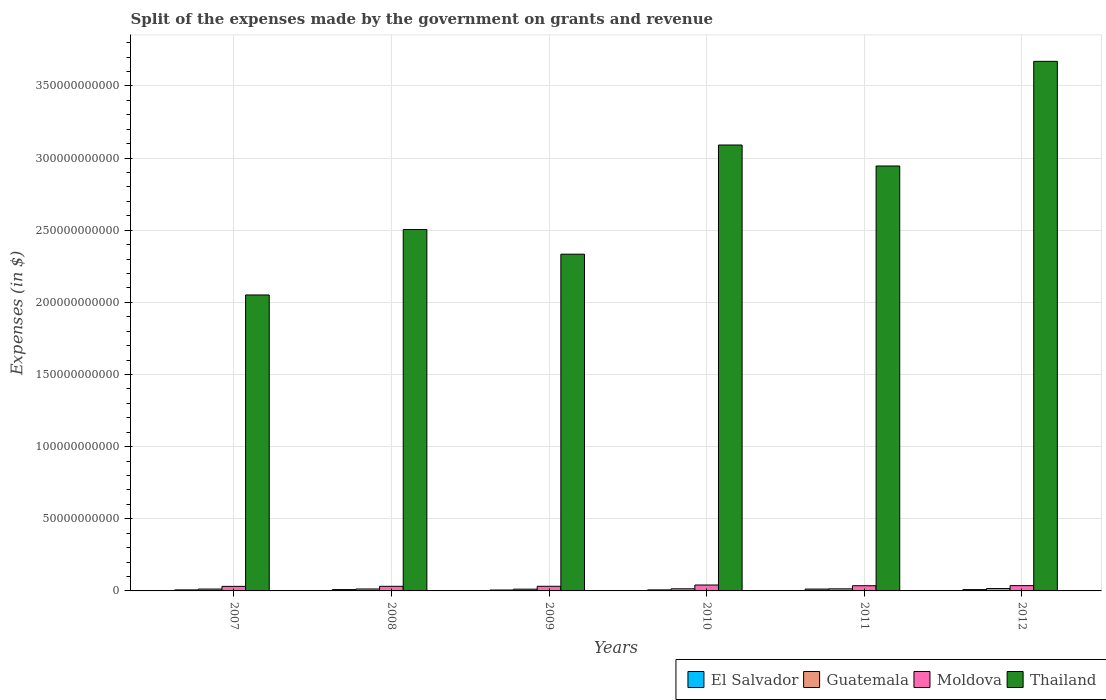How many groups of bars are there?
Offer a very short reply. 6. Are the number of bars per tick equal to the number of legend labels?
Give a very brief answer. Yes. In how many cases, is the number of bars for a given year not equal to the number of legend labels?
Provide a short and direct response. 0. What is the expenses made by the government on grants and revenue in El Salvador in 2010?
Keep it short and to the point. 7.09e+08. Across all years, what is the maximum expenses made by the government on grants and revenue in Thailand?
Your response must be concise. 3.67e+11. Across all years, what is the minimum expenses made by the government on grants and revenue in Guatemala?
Offer a terse response. 1.22e+09. In which year was the expenses made by the government on grants and revenue in Guatemala minimum?
Provide a short and direct response. 2009. What is the total expenses made by the government on grants and revenue in El Salvador in the graph?
Keep it short and to the point. 5.16e+09. What is the difference between the expenses made by the government on grants and revenue in Thailand in 2008 and that in 2012?
Provide a short and direct response. -1.17e+11. What is the difference between the expenses made by the government on grants and revenue in Guatemala in 2010 and the expenses made by the government on grants and revenue in Moldova in 2012?
Your answer should be very brief. -2.20e+09. What is the average expenses made by the government on grants and revenue in El Salvador per year?
Your response must be concise. 8.60e+08. In the year 2010, what is the difference between the expenses made by the government on grants and revenue in Guatemala and expenses made by the government on grants and revenue in El Salvador?
Offer a terse response. 7.56e+08. In how many years, is the expenses made by the government on grants and revenue in Thailand greater than 40000000000 $?
Provide a short and direct response. 6. What is the ratio of the expenses made by the government on grants and revenue in El Salvador in 2008 to that in 2010?
Provide a succinct answer. 1.3. Is the expenses made by the government on grants and revenue in Thailand in 2008 less than that in 2012?
Keep it short and to the point. Yes. Is the difference between the expenses made by the government on grants and revenue in Guatemala in 2008 and 2010 greater than the difference between the expenses made by the government on grants and revenue in El Salvador in 2008 and 2010?
Your answer should be compact. No. What is the difference between the highest and the second highest expenses made by the government on grants and revenue in Guatemala?
Your answer should be very brief. 1.70e+08. What is the difference between the highest and the lowest expenses made by the government on grants and revenue in Moldova?
Provide a succinct answer. 9.43e+08. In how many years, is the expenses made by the government on grants and revenue in Moldova greater than the average expenses made by the government on grants and revenue in Moldova taken over all years?
Your answer should be compact. 3. What does the 4th bar from the left in 2007 represents?
Keep it short and to the point. Thailand. What does the 1st bar from the right in 2009 represents?
Provide a short and direct response. Thailand. Is it the case that in every year, the sum of the expenses made by the government on grants and revenue in Thailand and expenses made by the government on grants and revenue in El Salvador is greater than the expenses made by the government on grants and revenue in Guatemala?
Provide a short and direct response. Yes. Are all the bars in the graph horizontal?
Offer a terse response. No. How many years are there in the graph?
Give a very brief answer. 6. What is the difference between two consecutive major ticks on the Y-axis?
Give a very brief answer. 5.00e+1. Does the graph contain grids?
Keep it short and to the point. Yes. How many legend labels are there?
Your answer should be compact. 4. How are the legend labels stacked?
Offer a terse response. Horizontal. What is the title of the graph?
Your answer should be compact. Split of the expenses made by the government on grants and revenue. Does "Virgin Islands" appear as one of the legend labels in the graph?
Your answer should be very brief. No. What is the label or title of the Y-axis?
Offer a very short reply. Expenses (in $). What is the Expenses (in $) in El Salvador in 2007?
Your answer should be very brief. 7.05e+08. What is the Expenses (in $) of Guatemala in 2007?
Keep it short and to the point. 1.30e+09. What is the Expenses (in $) in Moldova in 2007?
Offer a terse response. 3.16e+09. What is the Expenses (in $) in Thailand in 2007?
Offer a terse response. 2.05e+11. What is the Expenses (in $) of El Salvador in 2008?
Your answer should be very brief. 9.26e+08. What is the Expenses (in $) of Guatemala in 2008?
Give a very brief answer. 1.35e+09. What is the Expenses (in $) in Moldova in 2008?
Offer a terse response. 3.19e+09. What is the Expenses (in $) of Thailand in 2008?
Ensure brevity in your answer.  2.50e+11. What is the Expenses (in $) of El Salvador in 2009?
Give a very brief answer. 6.34e+08. What is the Expenses (in $) of Guatemala in 2009?
Provide a succinct answer. 1.22e+09. What is the Expenses (in $) of Moldova in 2009?
Your answer should be compact. 3.21e+09. What is the Expenses (in $) of Thailand in 2009?
Your answer should be compact. 2.33e+11. What is the Expenses (in $) of El Salvador in 2010?
Ensure brevity in your answer.  7.09e+08. What is the Expenses (in $) of Guatemala in 2010?
Offer a very short reply. 1.47e+09. What is the Expenses (in $) in Moldova in 2010?
Offer a very short reply. 4.10e+09. What is the Expenses (in $) of Thailand in 2010?
Your answer should be very brief. 3.09e+11. What is the Expenses (in $) in El Salvador in 2011?
Make the answer very short. 1.28e+09. What is the Expenses (in $) of Guatemala in 2011?
Provide a succinct answer. 1.44e+09. What is the Expenses (in $) in Moldova in 2011?
Provide a succinct answer. 3.61e+09. What is the Expenses (in $) in Thailand in 2011?
Provide a succinct answer. 2.95e+11. What is the Expenses (in $) in El Salvador in 2012?
Make the answer very short. 9.08e+08. What is the Expenses (in $) of Guatemala in 2012?
Your response must be concise. 1.64e+09. What is the Expenses (in $) of Moldova in 2012?
Offer a very short reply. 3.66e+09. What is the Expenses (in $) of Thailand in 2012?
Your answer should be compact. 3.67e+11. Across all years, what is the maximum Expenses (in $) of El Salvador?
Your response must be concise. 1.28e+09. Across all years, what is the maximum Expenses (in $) of Guatemala?
Keep it short and to the point. 1.64e+09. Across all years, what is the maximum Expenses (in $) of Moldova?
Keep it short and to the point. 4.10e+09. Across all years, what is the maximum Expenses (in $) of Thailand?
Provide a short and direct response. 3.67e+11. Across all years, what is the minimum Expenses (in $) in El Salvador?
Your answer should be compact. 6.34e+08. Across all years, what is the minimum Expenses (in $) of Guatemala?
Provide a short and direct response. 1.22e+09. Across all years, what is the minimum Expenses (in $) in Moldova?
Provide a short and direct response. 3.16e+09. Across all years, what is the minimum Expenses (in $) of Thailand?
Your answer should be compact. 2.05e+11. What is the total Expenses (in $) in El Salvador in the graph?
Offer a very short reply. 5.16e+09. What is the total Expenses (in $) in Guatemala in the graph?
Your response must be concise. 8.40e+09. What is the total Expenses (in $) in Moldova in the graph?
Ensure brevity in your answer.  2.09e+1. What is the total Expenses (in $) in Thailand in the graph?
Offer a very short reply. 1.66e+12. What is the difference between the Expenses (in $) in El Salvador in 2007 and that in 2008?
Make the answer very short. -2.20e+08. What is the difference between the Expenses (in $) in Guatemala in 2007 and that in 2008?
Offer a terse response. -4.95e+07. What is the difference between the Expenses (in $) of Moldova in 2007 and that in 2008?
Your answer should be compact. -3.39e+07. What is the difference between the Expenses (in $) of Thailand in 2007 and that in 2008?
Offer a very short reply. -4.54e+1. What is the difference between the Expenses (in $) in El Salvador in 2007 and that in 2009?
Your answer should be compact. 7.15e+07. What is the difference between the Expenses (in $) of Guatemala in 2007 and that in 2009?
Your response must be concise. 8.03e+07. What is the difference between the Expenses (in $) in Moldova in 2007 and that in 2009?
Give a very brief answer. -4.89e+07. What is the difference between the Expenses (in $) of Thailand in 2007 and that in 2009?
Give a very brief answer. -2.83e+1. What is the difference between the Expenses (in $) of El Salvador in 2007 and that in 2010?
Provide a short and direct response. -4.20e+06. What is the difference between the Expenses (in $) of Guatemala in 2007 and that in 2010?
Offer a very short reply. -1.69e+08. What is the difference between the Expenses (in $) of Moldova in 2007 and that in 2010?
Ensure brevity in your answer.  -9.43e+08. What is the difference between the Expenses (in $) in Thailand in 2007 and that in 2010?
Your response must be concise. -1.04e+11. What is the difference between the Expenses (in $) of El Salvador in 2007 and that in 2011?
Your response must be concise. -5.74e+08. What is the difference between the Expenses (in $) in Guatemala in 2007 and that in 2011?
Offer a terse response. -1.44e+08. What is the difference between the Expenses (in $) in Moldova in 2007 and that in 2011?
Keep it short and to the point. -4.45e+08. What is the difference between the Expenses (in $) of Thailand in 2007 and that in 2011?
Your response must be concise. -8.94e+1. What is the difference between the Expenses (in $) in El Salvador in 2007 and that in 2012?
Your response must be concise. -2.03e+08. What is the difference between the Expenses (in $) in Guatemala in 2007 and that in 2012?
Give a very brief answer. -3.39e+08. What is the difference between the Expenses (in $) of Moldova in 2007 and that in 2012?
Provide a short and direct response. -5.01e+08. What is the difference between the Expenses (in $) of Thailand in 2007 and that in 2012?
Keep it short and to the point. -1.62e+11. What is the difference between the Expenses (in $) of El Salvador in 2008 and that in 2009?
Your response must be concise. 2.92e+08. What is the difference between the Expenses (in $) in Guatemala in 2008 and that in 2009?
Offer a terse response. 1.30e+08. What is the difference between the Expenses (in $) of Moldova in 2008 and that in 2009?
Provide a short and direct response. -1.50e+07. What is the difference between the Expenses (in $) of Thailand in 2008 and that in 2009?
Give a very brief answer. 1.71e+1. What is the difference between the Expenses (in $) in El Salvador in 2008 and that in 2010?
Offer a terse response. 2.16e+08. What is the difference between the Expenses (in $) of Guatemala in 2008 and that in 2010?
Give a very brief answer. -1.20e+08. What is the difference between the Expenses (in $) in Moldova in 2008 and that in 2010?
Ensure brevity in your answer.  -9.09e+08. What is the difference between the Expenses (in $) of Thailand in 2008 and that in 2010?
Provide a succinct answer. -5.86e+1. What is the difference between the Expenses (in $) of El Salvador in 2008 and that in 2011?
Offer a very short reply. -3.54e+08. What is the difference between the Expenses (in $) of Guatemala in 2008 and that in 2011?
Your answer should be very brief. -9.49e+07. What is the difference between the Expenses (in $) of Moldova in 2008 and that in 2011?
Your answer should be compact. -4.11e+08. What is the difference between the Expenses (in $) in Thailand in 2008 and that in 2011?
Provide a short and direct response. -4.41e+1. What is the difference between the Expenses (in $) of El Salvador in 2008 and that in 2012?
Provide a succinct answer. 1.77e+07. What is the difference between the Expenses (in $) of Guatemala in 2008 and that in 2012?
Your answer should be compact. -2.90e+08. What is the difference between the Expenses (in $) of Moldova in 2008 and that in 2012?
Provide a succinct answer. -4.67e+08. What is the difference between the Expenses (in $) in Thailand in 2008 and that in 2012?
Make the answer very short. -1.17e+11. What is the difference between the Expenses (in $) in El Salvador in 2009 and that in 2010?
Keep it short and to the point. -7.57e+07. What is the difference between the Expenses (in $) in Guatemala in 2009 and that in 2010?
Offer a terse response. -2.49e+08. What is the difference between the Expenses (in $) in Moldova in 2009 and that in 2010?
Your response must be concise. -8.94e+08. What is the difference between the Expenses (in $) of Thailand in 2009 and that in 2010?
Provide a succinct answer. -7.57e+1. What is the difference between the Expenses (in $) in El Salvador in 2009 and that in 2011?
Your answer should be very brief. -6.46e+08. What is the difference between the Expenses (in $) of Guatemala in 2009 and that in 2011?
Provide a short and direct response. -2.25e+08. What is the difference between the Expenses (in $) in Moldova in 2009 and that in 2011?
Offer a very short reply. -3.96e+08. What is the difference between the Expenses (in $) in Thailand in 2009 and that in 2011?
Your answer should be compact. -6.11e+1. What is the difference between the Expenses (in $) of El Salvador in 2009 and that in 2012?
Offer a terse response. -2.74e+08. What is the difference between the Expenses (in $) of Guatemala in 2009 and that in 2012?
Provide a succinct answer. -4.20e+08. What is the difference between the Expenses (in $) of Moldova in 2009 and that in 2012?
Your response must be concise. -4.52e+08. What is the difference between the Expenses (in $) in Thailand in 2009 and that in 2012?
Your response must be concise. -1.34e+11. What is the difference between the Expenses (in $) in El Salvador in 2010 and that in 2011?
Keep it short and to the point. -5.70e+08. What is the difference between the Expenses (in $) in Guatemala in 2010 and that in 2011?
Your response must be concise. 2.46e+07. What is the difference between the Expenses (in $) in Moldova in 2010 and that in 2011?
Keep it short and to the point. 4.98e+08. What is the difference between the Expenses (in $) in Thailand in 2010 and that in 2011?
Offer a very short reply. 1.45e+1. What is the difference between the Expenses (in $) in El Salvador in 2010 and that in 2012?
Provide a short and direct response. -1.98e+08. What is the difference between the Expenses (in $) of Guatemala in 2010 and that in 2012?
Make the answer very short. -1.70e+08. What is the difference between the Expenses (in $) in Moldova in 2010 and that in 2012?
Give a very brief answer. 4.42e+08. What is the difference between the Expenses (in $) of Thailand in 2010 and that in 2012?
Keep it short and to the point. -5.80e+1. What is the difference between the Expenses (in $) of El Salvador in 2011 and that in 2012?
Your answer should be very brief. 3.72e+08. What is the difference between the Expenses (in $) of Guatemala in 2011 and that in 2012?
Your response must be concise. -1.95e+08. What is the difference between the Expenses (in $) in Moldova in 2011 and that in 2012?
Provide a succinct answer. -5.60e+07. What is the difference between the Expenses (in $) of Thailand in 2011 and that in 2012?
Give a very brief answer. -7.25e+1. What is the difference between the Expenses (in $) in El Salvador in 2007 and the Expenses (in $) in Guatemala in 2008?
Provide a succinct answer. -6.41e+08. What is the difference between the Expenses (in $) in El Salvador in 2007 and the Expenses (in $) in Moldova in 2008?
Your response must be concise. -2.49e+09. What is the difference between the Expenses (in $) of El Salvador in 2007 and the Expenses (in $) of Thailand in 2008?
Offer a very short reply. -2.50e+11. What is the difference between the Expenses (in $) in Guatemala in 2007 and the Expenses (in $) in Moldova in 2008?
Give a very brief answer. -1.90e+09. What is the difference between the Expenses (in $) of Guatemala in 2007 and the Expenses (in $) of Thailand in 2008?
Ensure brevity in your answer.  -2.49e+11. What is the difference between the Expenses (in $) in Moldova in 2007 and the Expenses (in $) in Thailand in 2008?
Provide a succinct answer. -2.47e+11. What is the difference between the Expenses (in $) in El Salvador in 2007 and the Expenses (in $) in Guatemala in 2009?
Offer a very short reply. -5.11e+08. What is the difference between the Expenses (in $) in El Salvador in 2007 and the Expenses (in $) in Moldova in 2009?
Keep it short and to the point. -2.50e+09. What is the difference between the Expenses (in $) of El Salvador in 2007 and the Expenses (in $) of Thailand in 2009?
Provide a succinct answer. -2.33e+11. What is the difference between the Expenses (in $) of Guatemala in 2007 and the Expenses (in $) of Moldova in 2009?
Give a very brief answer. -1.91e+09. What is the difference between the Expenses (in $) of Guatemala in 2007 and the Expenses (in $) of Thailand in 2009?
Offer a terse response. -2.32e+11. What is the difference between the Expenses (in $) of Moldova in 2007 and the Expenses (in $) of Thailand in 2009?
Your response must be concise. -2.30e+11. What is the difference between the Expenses (in $) in El Salvador in 2007 and the Expenses (in $) in Guatemala in 2010?
Provide a succinct answer. -7.60e+08. What is the difference between the Expenses (in $) of El Salvador in 2007 and the Expenses (in $) of Moldova in 2010?
Provide a short and direct response. -3.40e+09. What is the difference between the Expenses (in $) in El Salvador in 2007 and the Expenses (in $) in Thailand in 2010?
Your answer should be compact. -3.08e+11. What is the difference between the Expenses (in $) of Guatemala in 2007 and the Expenses (in $) of Moldova in 2010?
Make the answer very short. -2.81e+09. What is the difference between the Expenses (in $) of Guatemala in 2007 and the Expenses (in $) of Thailand in 2010?
Ensure brevity in your answer.  -3.08e+11. What is the difference between the Expenses (in $) in Moldova in 2007 and the Expenses (in $) in Thailand in 2010?
Give a very brief answer. -3.06e+11. What is the difference between the Expenses (in $) of El Salvador in 2007 and the Expenses (in $) of Guatemala in 2011?
Provide a succinct answer. -7.36e+08. What is the difference between the Expenses (in $) of El Salvador in 2007 and the Expenses (in $) of Moldova in 2011?
Offer a terse response. -2.90e+09. What is the difference between the Expenses (in $) of El Salvador in 2007 and the Expenses (in $) of Thailand in 2011?
Make the answer very short. -2.94e+11. What is the difference between the Expenses (in $) of Guatemala in 2007 and the Expenses (in $) of Moldova in 2011?
Your answer should be compact. -2.31e+09. What is the difference between the Expenses (in $) of Guatemala in 2007 and the Expenses (in $) of Thailand in 2011?
Offer a terse response. -2.93e+11. What is the difference between the Expenses (in $) in Moldova in 2007 and the Expenses (in $) in Thailand in 2011?
Ensure brevity in your answer.  -2.91e+11. What is the difference between the Expenses (in $) of El Salvador in 2007 and the Expenses (in $) of Guatemala in 2012?
Offer a terse response. -9.30e+08. What is the difference between the Expenses (in $) in El Salvador in 2007 and the Expenses (in $) in Moldova in 2012?
Your response must be concise. -2.96e+09. What is the difference between the Expenses (in $) in El Salvador in 2007 and the Expenses (in $) in Thailand in 2012?
Your answer should be very brief. -3.66e+11. What is the difference between the Expenses (in $) of Guatemala in 2007 and the Expenses (in $) of Moldova in 2012?
Ensure brevity in your answer.  -2.36e+09. What is the difference between the Expenses (in $) in Guatemala in 2007 and the Expenses (in $) in Thailand in 2012?
Provide a short and direct response. -3.66e+11. What is the difference between the Expenses (in $) of Moldova in 2007 and the Expenses (in $) of Thailand in 2012?
Your answer should be very brief. -3.64e+11. What is the difference between the Expenses (in $) in El Salvador in 2008 and the Expenses (in $) in Guatemala in 2009?
Your answer should be very brief. -2.91e+08. What is the difference between the Expenses (in $) in El Salvador in 2008 and the Expenses (in $) in Moldova in 2009?
Make the answer very short. -2.28e+09. What is the difference between the Expenses (in $) in El Salvador in 2008 and the Expenses (in $) in Thailand in 2009?
Your response must be concise. -2.32e+11. What is the difference between the Expenses (in $) of Guatemala in 2008 and the Expenses (in $) of Moldova in 2009?
Offer a very short reply. -1.86e+09. What is the difference between the Expenses (in $) in Guatemala in 2008 and the Expenses (in $) in Thailand in 2009?
Your answer should be very brief. -2.32e+11. What is the difference between the Expenses (in $) of Moldova in 2008 and the Expenses (in $) of Thailand in 2009?
Your response must be concise. -2.30e+11. What is the difference between the Expenses (in $) of El Salvador in 2008 and the Expenses (in $) of Guatemala in 2010?
Offer a terse response. -5.40e+08. What is the difference between the Expenses (in $) of El Salvador in 2008 and the Expenses (in $) of Moldova in 2010?
Your answer should be compact. -3.18e+09. What is the difference between the Expenses (in $) in El Salvador in 2008 and the Expenses (in $) in Thailand in 2010?
Make the answer very short. -3.08e+11. What is the difference between the Expenses (in $) in Guatemala in 2008 and the Expenses (in $) in Moldova in 2010?
Keep it short and to the point. -2.76e+09. What is the difference between the Expenses (in $) in Guatemala in 2008 and the Expenses (in $) in Thailand in 2010?
Give a very brief answer. -3.08e+11. What is the difference between the Expenses (in $) in Moldova in 2008 and the Expenses (in $) in Thailand in 2010?
Ensure brevity in your answer.  -3.06e+11. What is the difference between the Expenses (in $) of El Salvador in 2008 and the Expenses (in $) of Guatemala in 2011?
Give a very brief answer. -5.15e+08. What is the difference between the Expenses (in $) in El Salvador in 2008 and the Expenses (in $) in Moldova in 2011?
Ensure brevity in your answer.  -2.68e+09. What is the difference between the Expenses (in $) in El Salvador in 2008 and the Expenses (in $) in Thailand in 2011?
Your response must be concise. -2.94e+11. What is the difference between the Expenses (in $) in Guatemala in 2008 and the Expenses (in $) in Moldova in 2011?
Your answer should be very brief. -2.26e+09. What is the difference between the Expenses (in $) of Guatemala in 2008 and the Expenses (in $) of Thailand in 2011?
Offer a terse response. -2.93e+11. What is the difference between the Expenses (in $) of Moldova in 2008 and the Expenses (in $) of Thailand in 2011?
Provide a succinct answer. -2.91e+11. What is the difference between the Expenses (in $) in El Salvador in 2008 and the Expenses (in $) in Guatemala in 2012?
Your response must be concise. -7.10e+08. What is the difference between the Expenses (in $) in El Salvador in 2008 and the Expenses (in $) in Moldova in 2012?
Your response must be concise. -2.74e+09. What is the difference between the Expenses (in $) of El Salvador in 2008 and the Expenses (in $) of Thailand in 2012?
Your answer should be compact. -3.66e+11. What is the difference between the Expenses (in $) in Guatemala in 2008 and the Expenses (in $) in Moldova in 2012?
Provide a short and direct response. -2.32e+09. What is the difference between the Expenses (in $) in Guatemala in 2008 and the Expenses (in $) in Thailand in 2012?
Your answer should be very brief. -3.66e+11. What is the difference between the Expenses (in $) of Moldova in 2008 and the Expenses (in $) of Thailand in 2012?
Keep it short and to the point. -3.64e+11. What is the difference between the Expenses (in $) of El Salvador in 2009 and the Expenses (in $) of Guatemala in 2010?
Your answer should be compact. -8.32e+08. What is the difference between the Expenses (in $) in El Salvador in 2009 and the Expenses (in $) in Moldova in 2010?
Provide a short and direct response. -3.47e+09. What is the difference between the Expenses (in $) of El Salvador in 2009 and the Expenses (in $) of Thailand in 2010?
Offer a very short reply. -3.08e+11. What is the difference between the Expenses (in $) in Guatemala in 2009 and the Expenses (in $) in Moldova in 2010?
Offer a very short reply. -2.89e+09. What is the difference between the Expenses (in $) in Guatemala in 2009 and the Expenses (in $) in Thailand in 2010?
Provide a succinct answer. -3.08e+11. What is the difference between the Expenses (in $) in Moldova in 2009 and the Expenses (in $) in Thailand in 2010?
Provide a succinct answer. -3.06e+11. What is the difference between the Expenses (in $) of El Salvador in 2009 and the Expenses (in $) of Guatemala in 2011?
Your response must be concise. -8.07e+08. What is the difference between the Expenses (in $) in El Salvador in 2009 and the Expenses (in $) in Moldova in 2011?
Your answer should be very brief. -2.97e+09. What is the difference between the Expenses (in $) in El Salvador in 2009 and the Expenses (in $) in Thailand in 2011?
Provide a short and direct response. -2.94e+11. What is the difference between the Expenses (in $) in Guatemala in 2009 and the Expenses (in $) in Moldova in 2011?
Provide a short and direct response. -2.39e+09. What is the difference between the Expenses (in $) in Guatemala in 2009 and the Expenses (in $) in Thailand in 2011?
Provide a succinct answer. -2.93e+11. What is the difference between the Expenses (in $) of Moldova in 2009 and the Expenses (in $) of Thailand in 2011?
Offer a terse response. -2.91e+11. What is the difference between the Expenses (in $) in El Salvador in 2009 and the Expenses (in $) in Guatemala in 2012?
Your response must be concise. -1.00e+09. What is the difference between the Expenses (in $) of El Salvador in 2009 and the Expenses (in $) of Moldova in 2012?
Offer a terse response. -3.03e+09. What is the difference between the Expenses (in $) of El Salvador in 2009 and the Expenses (in $) of Thailand in 2012?
Make the answer very short. -3.66e+11. What is the difference between the Expenses (in $) in Guatemala in 2009 and the Expenses (in $) in Moldova in 2012?
Provide a succinct answer. -2.45e+09. What is the difference between the Expenses (in $) in Guatemala in 2009 and the Expenses (in $) in Thailand in 2012?
Ensure brevity in your answer.  -3.66e+11. What is the difference between the Expenses (in $) of Moldova in 2009 and the Expenses (in $) of Thailand in 2012?
Provide a short and direct response. -3.64e+11. What is the difference between the Expenses (in $) in El Salvador in 2010 and the Expenses (in $) in Guatemala in 2011?
Provide a short and direct response. -7.31e+08. What is the difference between the Expenses (in $) of El Salvador in 2010 and the Expenses (in $) of Moldova in 2011?
Ensure brevity in your answer.  -2.90e+09. What is the difference between the Expenses (in $) of El Salvador in 2010 and the Expenses (in $) of Thailand in 2011?
Give a very brief answer. -2.94e+11. What is the difference between the Expenses (in $) of Guatemala in 2010 and the Expenses (in $) of Moldova in 2011?
Your response must be concise. -2.14e+09. What is the difference between the Expenses (in $) in Guatemala in 2010 and the Expenses (in $) in Thailand in 2011?
Offer a terse response. -2.93e+11. What is the difference between the Expenses (in $) in Moldova in 2010 and the Expenses (in $) in Thailand in 2011?
Provide a short and direct response. -2.90e+11. What is the difference between the Expenses (in $) of El Salvador in 2010 and the Expenses (in $) of Guatemala in 2012?
Keep it short and to the point. -9.26e+08. What is the difference between the Expenses (in $) in El Salvador in 2010 and the Expenses (in $) in Moldova in 2012?
Keep it short and to the point. -2.95e+09. What is the difference between the Expenses (in $) in El Salvador in 2010 and the Expenses (in $) in Thailand in 2012?
Your answer should be very brief. -3.66e+11. What is the difference between the Expenses (in $) of Guatemala in 2010 and the Expenses (in $) of Moldova in 2012?
Make the answer very short. -2.20e+09. What is the difference between the Expenses (in $) in Guatemala in 2010 and the Expenses (in $) in Thailand in 2012?
Your response must be concise. -3.66e+11. What is the difference between the Expenses (in $) of Moldova in 2010 and the Expenses (in $) of Thailand in 2012?
Give a very brief answer. -3.63e+11. What is the difference between the Expenses (in $) of El Salvador in 2011 and the Expenses (in $) of Guatemala in 2012?
Your answer should be very brief. -3.56e+08. What is the difference between the Expenses (in $) in El Salvador in 2011 and the Expenses (in $) in Moldova in 2012?
Ensure brevity in your answer.  -2.38e+09. What is the difference between the Expenses (in $) in El Salvador in 2011 and the Expenses (in $) in Thailand in 2012?
Provide a succinct answer. -3.66e+11. What is the difference between the Expenses (in $) in Guatemala in 2011 and the Expenses (in $) in Moldova in 2012?
Give a very brief answer. -2.22e+09. What is the difference between the Expenses (in $) in Guatemala in 2011 and the Expenses (in $) in Thailand in 2012?
Offer a very short reply. -3.66e+11. What is the difference between the Expenses (in $) of Moldova in 2011 and the Expenses (in $) of Thailand in 2012?
Keep it short and to the point. -3.63e+11. What is the average Expenses (in $) of El Salvador per year?
Keep it short and to the point. 8.60e+08. What is the average Expenses (in $) in Guatemala per year?
Give a very brief answer. 1.40e+09. What is the average Expenses (in $) in Moldova per year?
Your answer should be compact. 3.49e+09. What is the average Expenses (in $) in Thailand per year?
Provide a short and direct response. 2.77e+11. In the year 2007, what is the difference between the Expenses (in $) in El Salvador and Expenses (in $) in Guatemala?
Keep it short and to the point. -5.91e+08. In the year 2007, what is the difference between the Expenses (in $) of El Salvador and Expenses (in $) of Moldova?
Provide a short and direct response. -2.46e+09. In the year 2007, what is the difference between the Expenses (in $) in El Salvador and Expenses (in $) in Thailand?
Your answer should be compact. -2.04e+11. In the year 2007, what is the difference between the Expenses (in $) of Guatemala and Expenses (in $) of Moldova?
Give a very brief answer. -1.86e+09. In the year 2007, what is the difference between the Expenses (in $) of Guatemala and Expenses (in $) of Thailand?
Give a very brief answer. -2.04e+11. In the year 2007, what is the difference between the Expenses (in $) of Moldova and Expenses (in $) of Thailand?
Make the answer very short. -2.02e+11. In the year 2008, what is the difference between the Expenses (in $) in El Salvador and Expenses (in $) in Guatemala?
Provide a succinct answer. -4.20e+08. In the year 2008, what is the difference between the Expenses (in $) of El Salvador and Expenses (in $) of Moldova?
Give a very brief answer. -2.27e+09. In the year 2008, what is the difference between the Expenses (in $) of El Salvador and Expenses (in $) of Thailand?
Your answer should be compact. -2.50e+11. In the year 2008, what is the difference between the Expenses (in $) in Guatemala and Expenses (in $) in Moldova?
Your answer should be compact. -1.85e+09. In the year 2008, what is the difference between the Expenses (in $) in Guatemala and Expenses (in $) in Thailand?
Your answer should be compact. -2.49e+11. In the year 2008, what is the difference between the Expenses (in $) in Moldova and Expenses (in $) in Thailand?
Offer a very short reply. -2.47e+11. In the year 2009, what is the difference between the Expenses (in $) in El Salvador and Expenses (in $) in Guatemala?
Your response must be concise. -5.82e+08. In the year 2009, what is the difference between the Expenses (in $) of El Salvador and Expenses (in $) of Moldova?
Offer a very short reply. -2.58e+09. In the year 2009, what is the difference between the Expenses (in $) in El Salvador and Expenses (in $) in Thailand?
Make the answer very short. -2.33e+11. In the year 2009, what is the difference between the Expenses (in $) in Guatemala and Expenses (in $) in Moldova?
Ensure brevity in your answer.  -1.99e+09. In the year 2009, what is the difference between the Expenses (in $) in Guatemala and Expenses (in $) in Thailand?
Offer a terse response. -2.32e+11. In the year 2009, what is the difference between the Expenses (in $) in Moldova and Expenses (in $) in Thailand?
Give a very brief answer. -2.30e+11. In the year 2010, what is the difference between the Expenses (in $) in El Salvador and Expenses (in $) in Guatemala?
Your answer should be compact. -7.56e+08. In the year 2010, what is the difference between the Expenses (in $) in El Salvador and Expenses (in $) in Moldova?
Provide a succinct answer. -3.39e+09. In the year 2010, what is the difference between the Expenses (in $) in El Salvador and Expenses (in $) in Thailand?
Provide a succinct answer. -3.08e+11. In the year 2010, what is the difference between the Expenses (in $) of Guatemala and Expenses (in $) of Moldova?
Your answer should be compact. -2.64e+09. In the year 2010, what is the difference between the Expenses (in $) in Guatemala and Expenses (in $) in Thailand?
Make the answer very short. -3.08e+11. In the year 2010, what is the difference between the Expenses (in $) of Moldova and Expenses (in $) of Thailand?
Provide a short and direct response. -3.05e+11. In the year 2011, what is the difference between the Expenses (in $) in El Salvador and Expenses (in $) in Guatemala?
Provide a succinct answer. -1.61e+08. In the year 2011, what is the difference between the Expenses (in $) of El Salvador and Expenses (in $) of Moldova?
Ensure brevity in your answer.  -2.33e+09. In the year 2011, what is the difference between the Expenses (in $) in El Salvador and Expenses (in $) in Thailand?
Your response must be concise. -2.93e+11. In the year 2011, what is the difference between the Expenses (in $) in Guatemala and Expenses (in $) in Moldova?
Make the answer very short. -2.16e+09. In the year 2011, what is the difference between the Expenses (in $) in Guatemala and Expenses (in $) in Thailand?
Your answer should be compact. -2.93e+11. In the year 2011, what is the difference between the Expenses (in $) of Moldova and Expenses (in $) of Thailand?
Your answer should be very brief. -2.91e+11. In the year 2012, what is the difference between the Expenses (in $) in El Salvador and Expenses (in $) in Guatemala?
Your answer should be compact. -7.28e+08. In the year 2012, what is the difference between the Expenses (in $) in El Salvador and Expenses (in $) in Moldova?
Provide a succinct answer. -2.75e+09. In the year 2012, what is the difference between the Expenses (in $) of El Salvador and Expenses (in $) of Thailand?
Provide a succinct answer. -3.66e+11. In the year 2012, what is the difference between the Expenses (in $) in Guatemala and Expenses (in $) in Moldova?
Keep it short and to the point. -2.03e+09. In the year 2012, what is the difference between the Expenses (in $) in Guatemala and Expenses (in $) in Thailand?
Provide a short and direct response. -3.65e+11. In the year 2012, what is the difference between the Expenses (in $) of Moldova and Expenses (in $) of Thailand?
Keep it short and to the point. -3.63e+11. What is the ratio of the Expenses (in $) of El Salvador in 2007 to that in 2008?
Provide a short and direct response. 0.76. What is the ratio of the Expenses (in $) in Guatemala in 2007 to that in 2008?
Keep it short and to the point. 0.96. What is the ratio of the Expenses (in $) in Thailand in 2007 to that in 2008?
Give a very brief answer. 0.82. What is the ratio of the Expenses (in $) of El Salvador in 2007 to that in 2009?
Your answer should be compact. 1.11. What is the ratio of the Expenses (in $) in Guatemala in 2007 to that in 2009?
Provide a succinct answer. 1.07. What is the ratio of the Expenses (in $) in Moldova in 2007 to that in 2009?
Provide a short and direct response. 0.98. What is the ratio of the Expenses (in $) of Thailand in 2007 to that in 2009?
Offer a terse response. 0.88. What is the ratio of the Expenses (in $) in El Salvador in 2007 to that in 2010?
Offer a terse response. 0.99. What is the ratio of the Expenses (in $) of Guatemala in 2007 to that in 2010?
Ensure brevity in your answer.  0.88. What is the ratio of the Expenses (in $) in Moldova in 2007 to that in 2010?
Make the answer very short. 0.77. What is the ratio of the Expenses (in $) in Thailand in 2007 to that in 2010?
Offer a very short reply. 0.66. What is the ratio of the Expenses (in $) in El Salvador in 2007 to that in 2011?
Your answer should be very brief. 0.55. What is the ratio of the Expenses (in $) of Guatemala in 2007 to that in 2011?
Your answer should be very brief. 0.9. What is the ratio of the Expenses (in $) in Moldova in 2007 to that in 2011?
Offer a very short reply. 0.88. What is the ratio of the Expenses (in $) of Thailand in 2007 to that in 2011?
Keep it short and to the point. 0.7. What is the ratio of the Expenses (in $) in El Salvador in 2007 to that in 2012?
Offer a terse response. 0.78. What is the ratio of the Expenses (in $) in Guatemala in 2007 to that in 2012?
Your answer should be compact. 0.79. What is the ratio of the Expenses (in $) in Moldova in 2007 to that in 2012?
Your answer should be compact. 0.86. What is the ratio of the Expenses (in $) in Thailand in 2007 to that in 2012?
Offer a very short reply. 0.56. What is the ratio of the Expenses (in $) of El Salvador in 2008 to that in 2009?
Your answer should be compact. 1.46. What is the ratio of the Expenses (in $) of Guatemala in 2008 to that in 2009?
Provide a short and direct response. 1.11. What is the ratio of the Expenses (in $) in Thailand in 2008 to that in 2009?
Your answer should be compact. 1.07. What is the ratio of the Expenses (in $) in El Salvador in 2008 to that in 2010?
Offer a very short reply. 1.3. What is the ratio of the Expenses (in $) in Guatemala in 2008 to that in 2010?
Provide a succinct answer. 0.92. What is the ratio of the Expenses (in $) in Moldova in 2008 to that in 2010?
Make the answer very short. 0.78. What is the ratio of the Expenses (in $) of Thailand in 2008 to that in 2010?
Offer a very short reply. 0.81. What is the ratio of the Expenses (in $) of El Salvador in 2008 to that in 2011?
Your answer should be compact. 0.72. What is the ratio of the Expenses (in $) of Guatemala in 2008 to that in 2011?
Offer a very short reply. 0.93. What is the ratio of the Expenses (in $) of Moldova in 2008 to that in 2011?
Make the answer very short. 0.89. What is the ratio of the Expenses (in $) in Thailand in 2008 to that in 2011?
Ensure brevity in your answer.  0.85. What is the ratio of the Expenses (in $) in El Salvador in 2008 to that in 2012?
Offer a terse response. 1.02. What is the ratio of the Expenses (in $) in Guatemala in 2008 to that in 2012?
Keep it short and to the point. 0.82. What is the ratio of the Expenses (in $) in Moldova in 2008 to that in 2012?
Give a very brief answer. 0.87. What is the ratio of the Expenses (in $) of Thailand in 2008 to that in 2012?
Your response must be concise. 0.68. What is the ratio of the Expenses (in $) in El Salvador in 2009 to that in 2010?
Keep it short and to the point. 0.89. What is the ratio of the Expenses (in $) in Guatemala in 2009 to that in 2010?
Give a very brief answer. 0.83. What is the ratio of the Expenses (in $) in Moldova in 2009 to that in 2010?
Offer a terse response. 0.78. What is the ratio of the Expenses (in $) of Thailand in 2009 to that in 2010?
Provide a succinct answer. 0.76. What is the ratio of the Expenses (in $) of El Salvador in 2009 to that in 2011?
Offer a terse response. 0.5. What is the ratio of the Expenses (in $) in Guatemala in 2009 to that in 2011?
Offer a very short reply. 0.84. What is the ratio of the Expenses (in $) in Moldova in 2009 to that in 2011?
Ensure brevity in your answer.  0.89. What is the ratio of the Expenses (in $) of Thailand in 2009 to that in 2011?
Provide a short and direct response. 0.79. What is the ratio of the Expenses (in $) of El Salvador in 2009 to that in 2012?
Offer a terse response. 0.7. What is the ratio of the Expenses (in $) in Guatemala in 2009 to that in 2012?
Provide a short and direct response. 0.74. What is the ratio of the Expenses (in $) of Moldova in 2009 to that in 2012?
Provide a succinct answer. 0.88. What is the ratio of the Expenses (in $) of Thailand in 2009 to that in 2012?
Your answer should be very brief. 0.64. What is the ratio of the Expenses (in $) in El Salvador in 2010 to that in 2011?
Offer a terse response. 0.55. What is the ratio of the Expenses (in $) of Guatemala in 2010 to that in 2011?
Your response must be concise. 1.02. What is the ratio of the Expenses (in $) in Moldova in 2010 to that in 2011?
Your answer should be compact. 1.14. What is the ratio of the Expenses (in $) in Thailand in 2010 to that in 2011?
Provide a succinct answer. 1.05. What is the ratio of the Expenses (in $) in El Salvador in 2010 to that in 2012?
Ensure brevity in your answer.  0.78. What is the ratio of the Expenses (in $) in Guatemala in 2010 to that in 2012?
Ensure brevity in your answer.  0.9. What is the ratio of the Expenses (in $) in Moldova in 2010 to that in 2012?
Make the answer very short. 1.12. What is the ratio of the Expenses (in $) in Thailand in 2010 to that in 2012?
Give a very brief answer. 0.84. What is the ratio of the Expenses (in $) of El Salvador in 2011 to that in 2012?
Your response must be concise. 1.41. What is the ratio of the Expenses (in $) in Guatemala in 2011 to that in 2012?
Ensure brevity in your answer.  0.88. What is the ratio of the Expenses (in $) in Moldova in 2011 to that in 2012?
Give a very brief answer. 0.98. What is the ratio of the Expenses (in $) in Thailand in 2011 to that in 2012?
Your answer should be very brief. 0.8. What is the difference between the highest and the second highest Expenses (in $) of El Salvador?
Ensure brevity in your answer.  3.54e+08. What is the difference between the highest and the second highest Expenses (in $) of Guatemala?
Provide a succinct answer. 1.70e+08. What is the difference between the highest and the second highest Expenses (in $) of Moldova?
Give a very brief answer. 4.42e+08. What is the difference between the highest and the second highest Expenses (in $) of Thailand?
Provide a succinct answer. 5.80e+1. What is the difference between the highest and the lowest Expenses (in $) of El Salvador?
Ensure brevity in your answer.  6.46e+08. What is the difference between the highest and the lowest Expenses (in $) of Guatemala?
Make the answer very short. 4.20e+08. What is the difference between the highest and the lowest Expenses (in $) of Moldova?
Give a very brief answer. 9.43e+08. What is the difference between the highest and the lowest Expenses (in $) in Thailand?
Keep it short and to the point. 1.62e+11. 